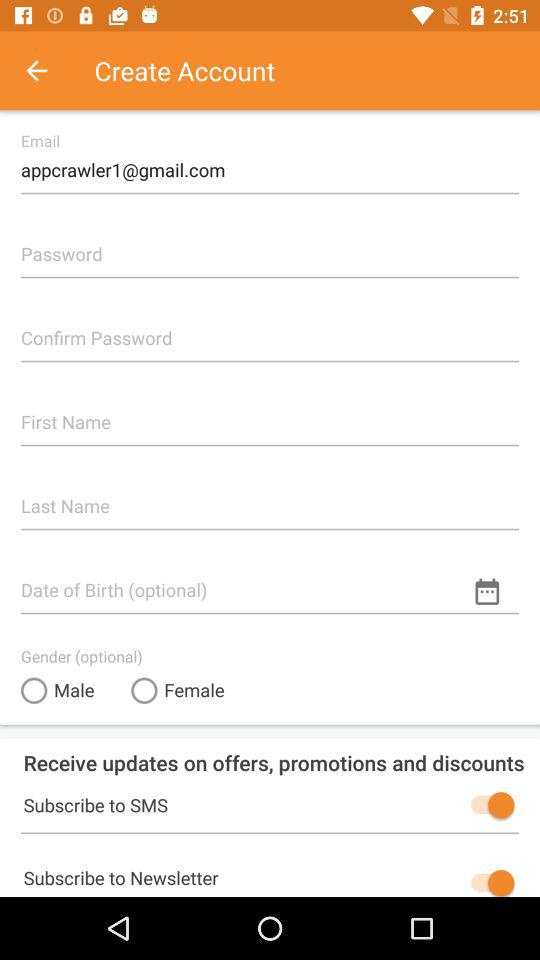What is the status of the "Subscribe to Newsletter"? The status is on. 